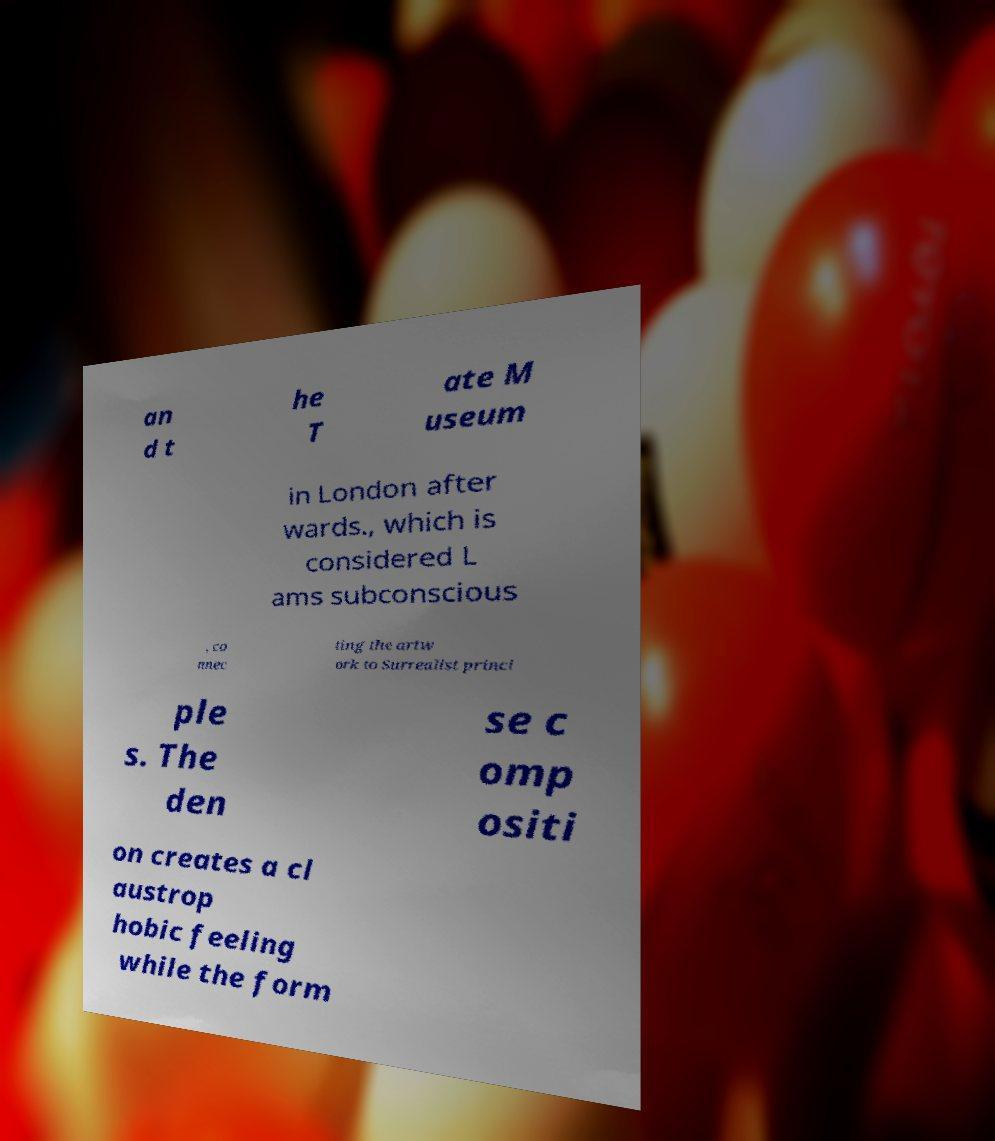Could you assist in decoding the text presented in this image and type it out clearly? an d t he T ate M useum in London after wards., which is considered L ams subconscious , co nnec ting the artw ork to Surrealist princi ple s. The den se c omp ositi on creates a cl austrop hobic feeling while the form 